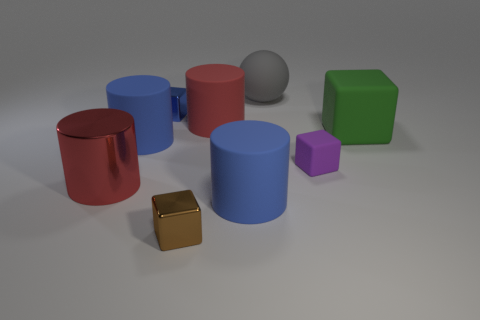Subtract all green cubes. How many cubes are left? 3 Subtract all blue cubes. How many cubes are left? 3 Subtract all gray cylinders. Subtract all yellow spheres. How many cylinders are left? 4 Subtract all spheres. How many objects are left? 8 Add 5 rubber blocks. How many rubber blocks exist? 7 Subtract 0 purple balls. How many objects are left? 9 Subtract all gray objects. Subtract all big gray matte balls. How many objects are left? 7 Add 5 tiny purple rubber objects. How many tiny purple rubber objects are left? 6 